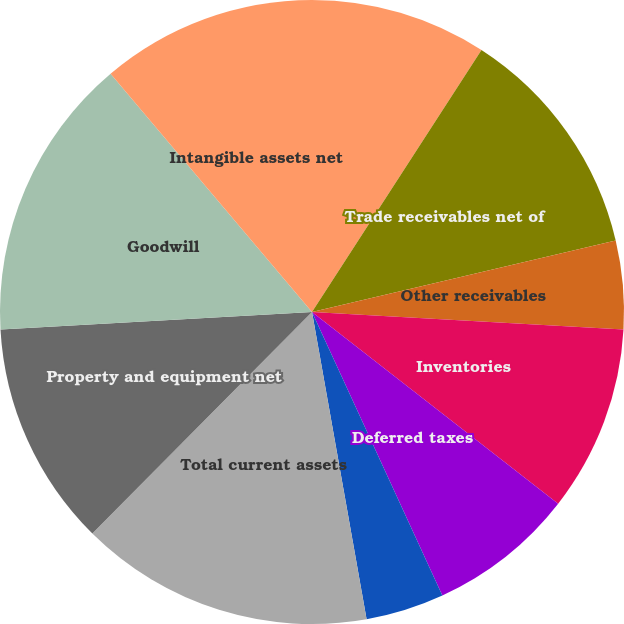<chart> <loc_0><loc_0><loc_500><loc_500><pie_chart><fcel>Cash and cash equivalents<fcel>Trade receivables net of<fcel>Other receivables<fcel>Inventories<fcel>Deferred taxes<fcel>Prepaid expenses and other<fcel>Total current assets<fcel>Property and equipment net<fcel>Goodwill<fcel>Intangible assets net<nl><fcel>9.14%<fcel>12.18%<fcel>4.57%<fcel>9.64%<fcel>7.61%<fcel>4.06%<fcel>15.23%<fcel>11.68%<fcel>14.72%<fcel>11.17%<nl></chart> 